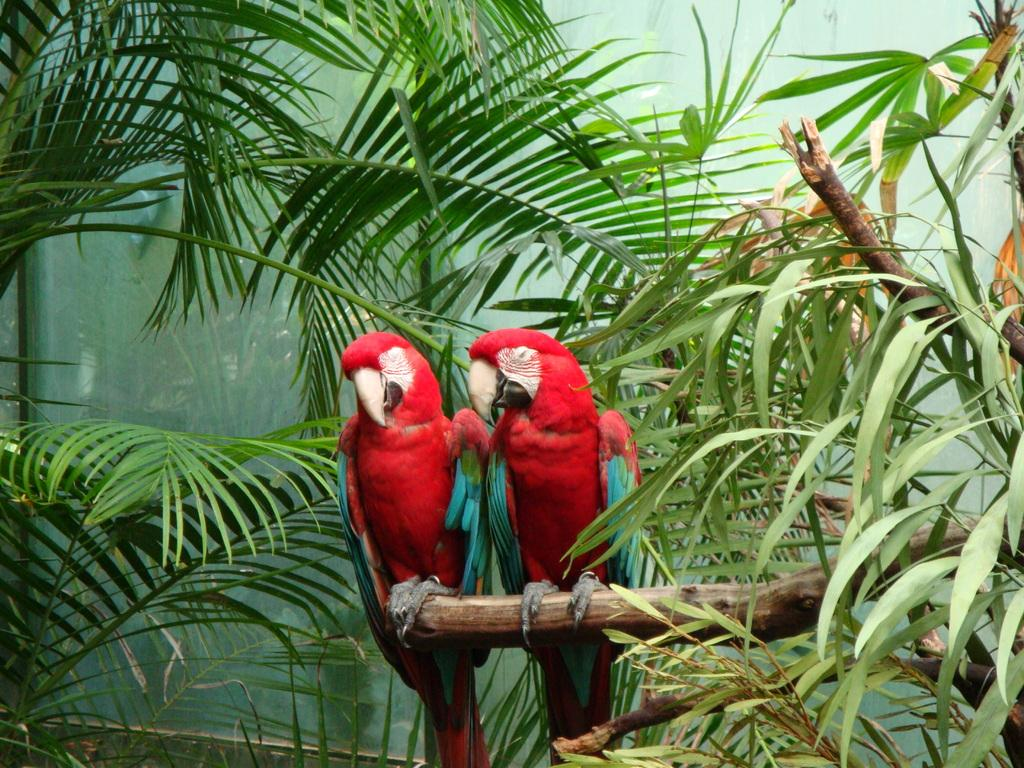What type of animals are in the image? There are parrots in the image. Where are the parrots located? The parrots are standing on a branch of a tree. What can be seen in the background of the image? There are leaves in the background of the image. What material is present in the image? There is glass in the image. What type of dust can be seen on the bike in the image? There is no bike present in the image, and therefore no dust can be observed on it. 